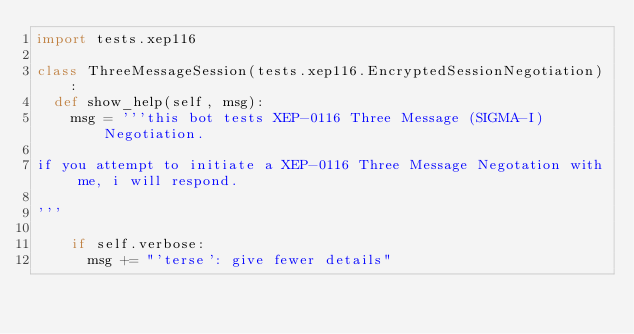Convert code to text. <code><loc_0><loc_0><loc_500><loc_500><_Python_>import tests.xep116

class ThreeMessageSession(tests.xep116.EncryptedSessionNegotiation):
  def show_help(self, msg):
    msg = '''this bot tests XEP-0116 Three Message (SIGMA-I) Negotiation.

if you attempt to initiate a XEP-0116 Three Message Negotation with me, i will respond.

'''

    if self.verbose:
      msg += "'terse': give fewer details"</code> 